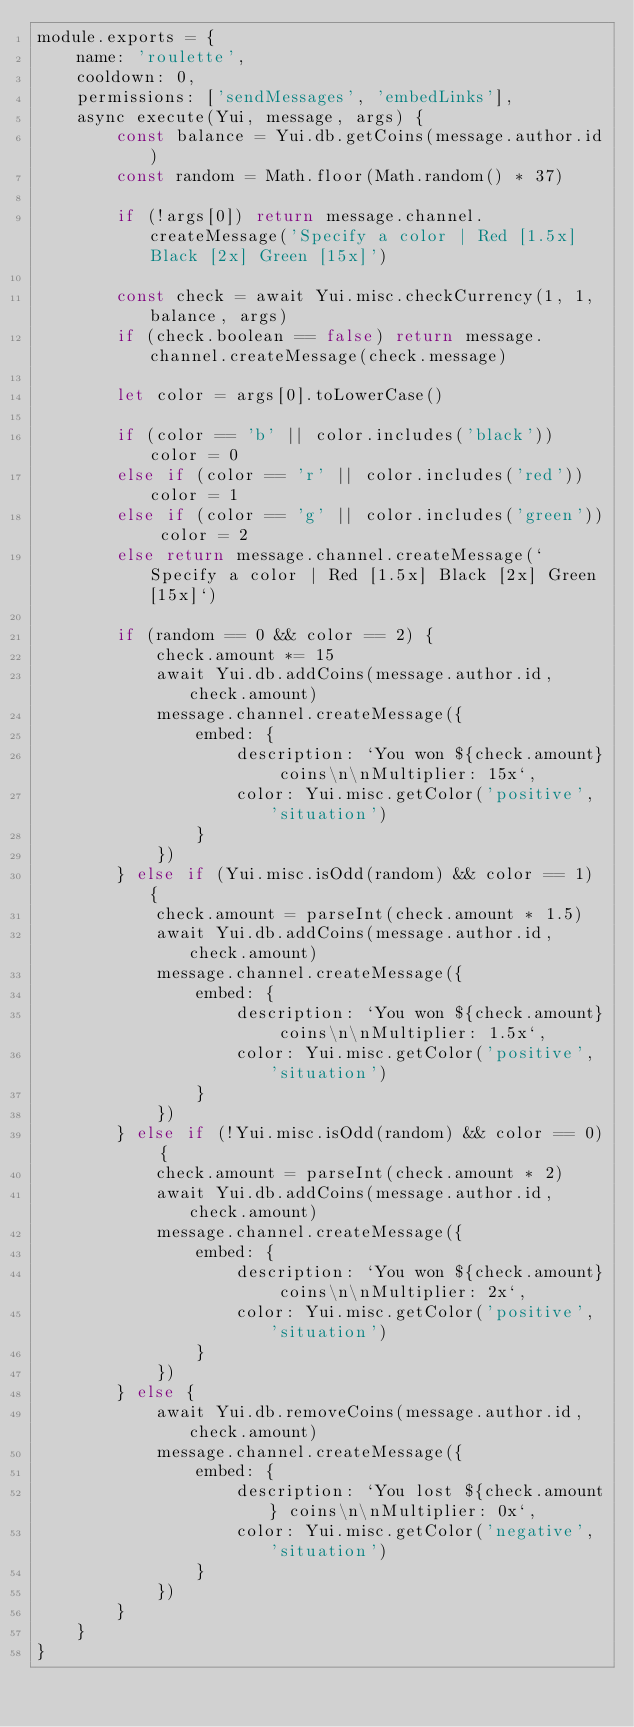<code> <loc_0><loc_0><loc_500><loc_500><_JavaScript_>module.exports = {
    name: 'roulette',
    cooldown: 0,
    permissions: ['sendMessages', 'embedLinks'],
    async execute(Yui, message, args) {
        const balance = Yui.db.getCoins(message.author.id)
        const random = Math.floor(Math.random() * 37)

        if (!args[0]) return message.channel.createMessage('Specify a color | Red [1.5x] Black [2x] Green [15x]')

        const check = await Yui.misc.checkCurrency(1, 1, balance, args)
        if (check.boolean == false) return message.channel.createMessage(check.message)

        let color = args[0].toLowerCase()

        if (color == 'b' || color.includes('black')) color = 0
        else if (color == 'r' || color.includes('red')) color = 1
        else if (color == 'g' || color.includes('green')) color = 2
        else return message.channel.createMessage(`Specify a color | Red [1.5x] Black [2x] Green [15x]`)

        if (random == 0 && color == 2) {
            check.amount *= 15
            await Yui.db.addCoins(message.author.id, check.amount)
            message.channel.createMessage({
                embed: {
                    description: `You won ${check.amount} coins\n\nMultiplier: 15x`,
                    color: Yui.misc.getColor('positive', 'situation')
                }
            })
        } else if (Yui.misc.isOdd(random) && color == 1) {
            check.amount = parseInt(check.amount * 1.5)
            await Yui.db.addCoins(message.author.id, check.amount)
            message.channel.createMessage({
                embed: {
                    description: `You won ${check.amount} coins\n\nMultiplier: 1.5x`,
                    color: Yui.misc.getColor('positive', 'situation')
                }
            })
        } else if (!Yui.misc.isOdd(random) && color == 0) {
            check.amount = parseInt(check.amount * 2)
            await Yui.db.addCoins(message.author.id, check.amount)
            message.channel.createMessage({
                embed: {
                    description: `You won ${check.amount} coins\n\nMultiplier: 2x`,
                    color: Yui.misc.getColor('positive', 'situation')
                }
            })
        } else {
            await Yui.db.removeCoins(message.author.id, check.amount)
            message.channel.createMessage({
                embed: {
                    description: `You lost ${check.amount} coins\n\nMultiplier: 0x`,
                    color: Yui.misc.getColor('negative', 'situation')
                }
            })
        }
    }
}</code> 